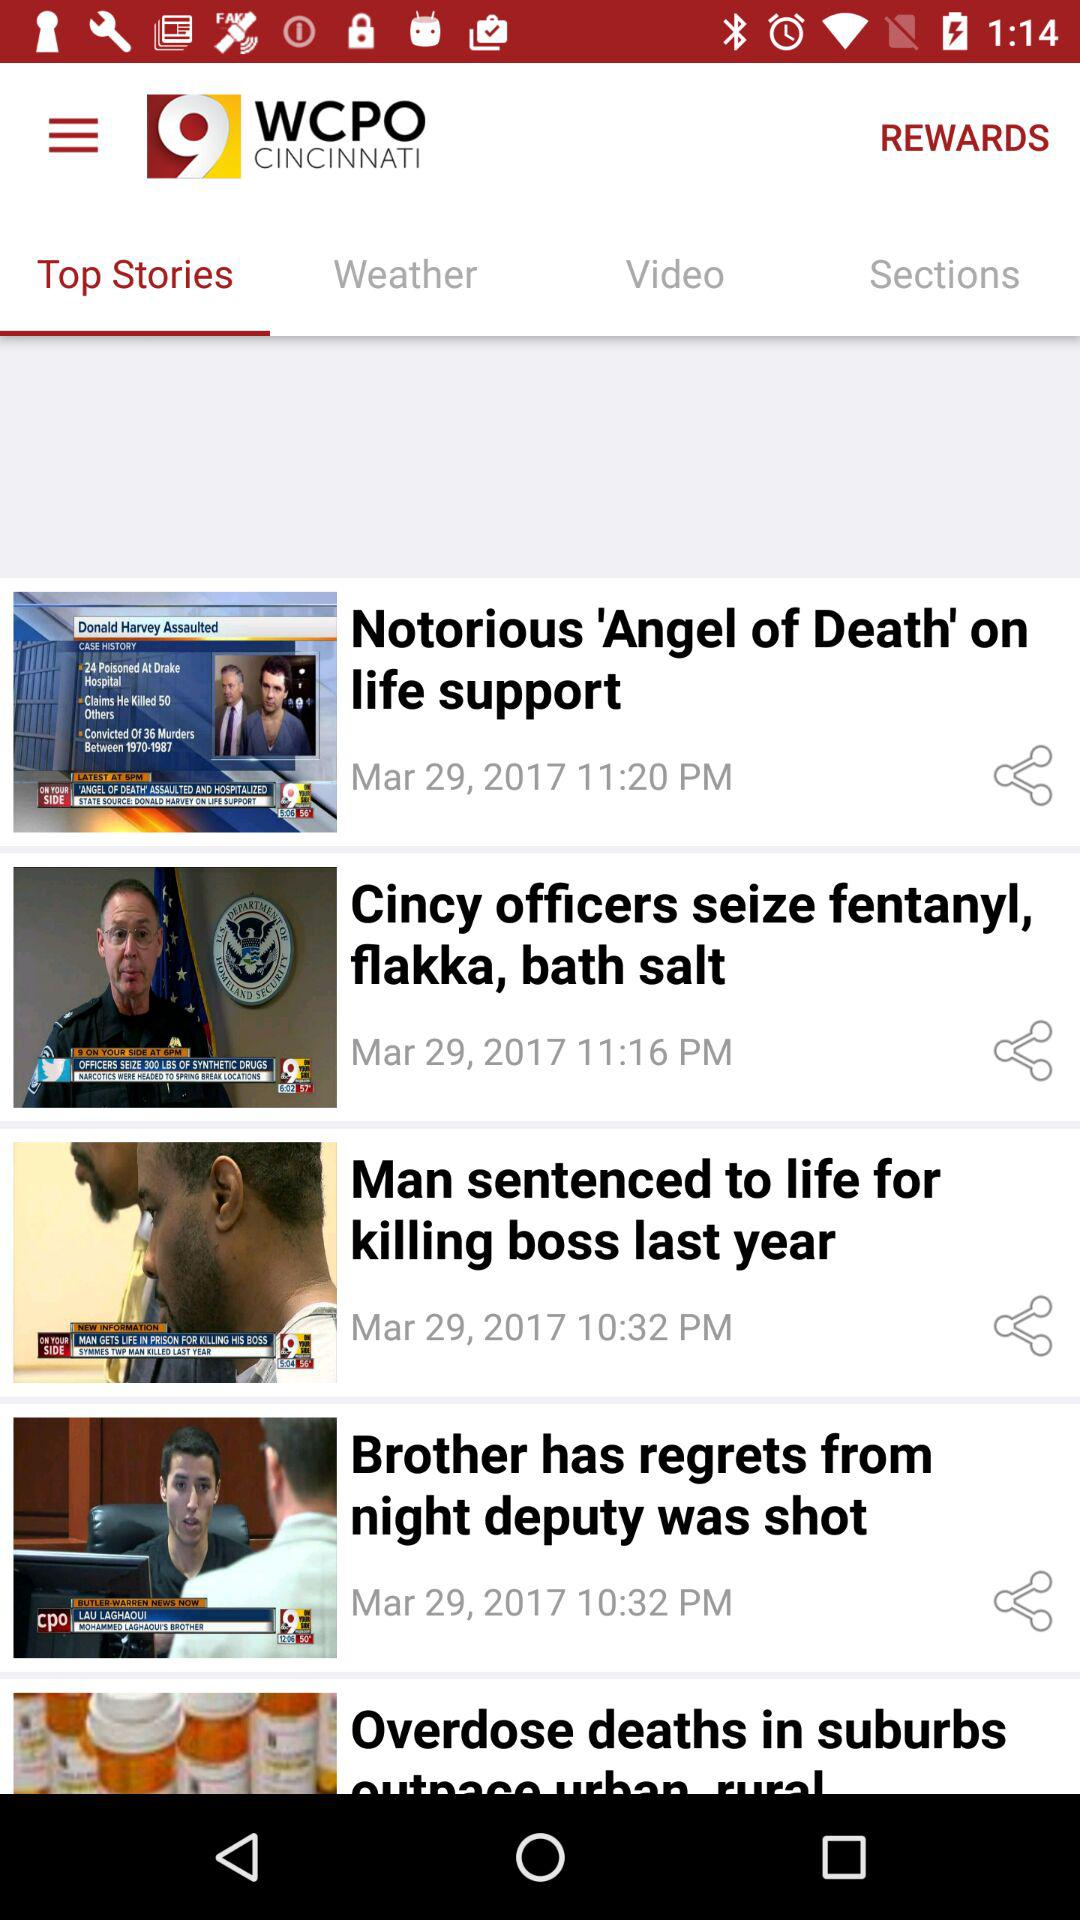What is the story that comes at 10:32 pm on March 29, 2017? The stories that comes at 10:32 pm on March 29, 2017 are "Man sentenced to life for killing boss last year" and "Brother has regrets from night deputy was shot". 